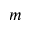Convert formula to latex. <formula><loc_0><loc_0><loc_500><loc_500>m</formula> 